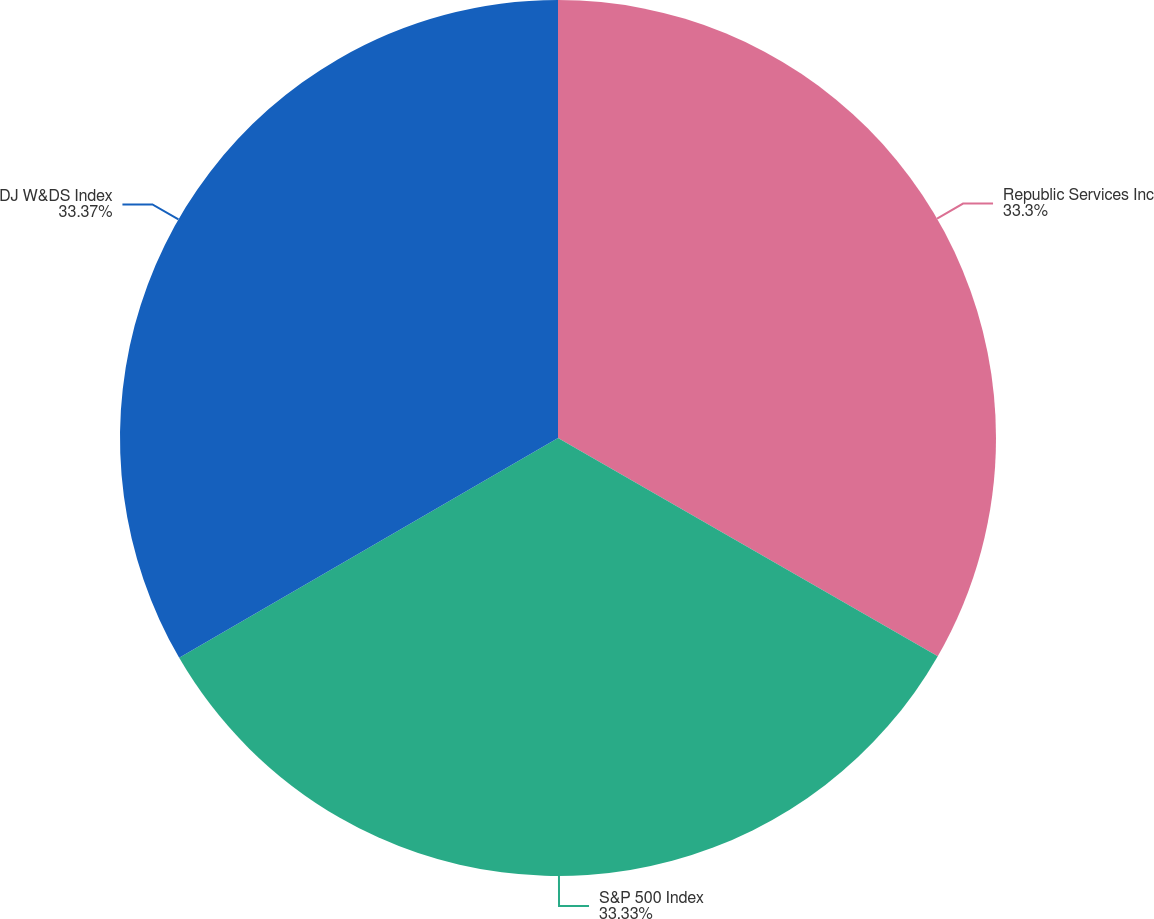Convert chart. <chart><loc_0><loc_0><loc_500><loc_500><pie_chart><fcel>Republic Services Inc<fcel>S&P 500 Index<fcel>DJ W&DS Index<nl><fcel>33.3%<fcel>33.33%<fcel>33.37%<nl></chart> 